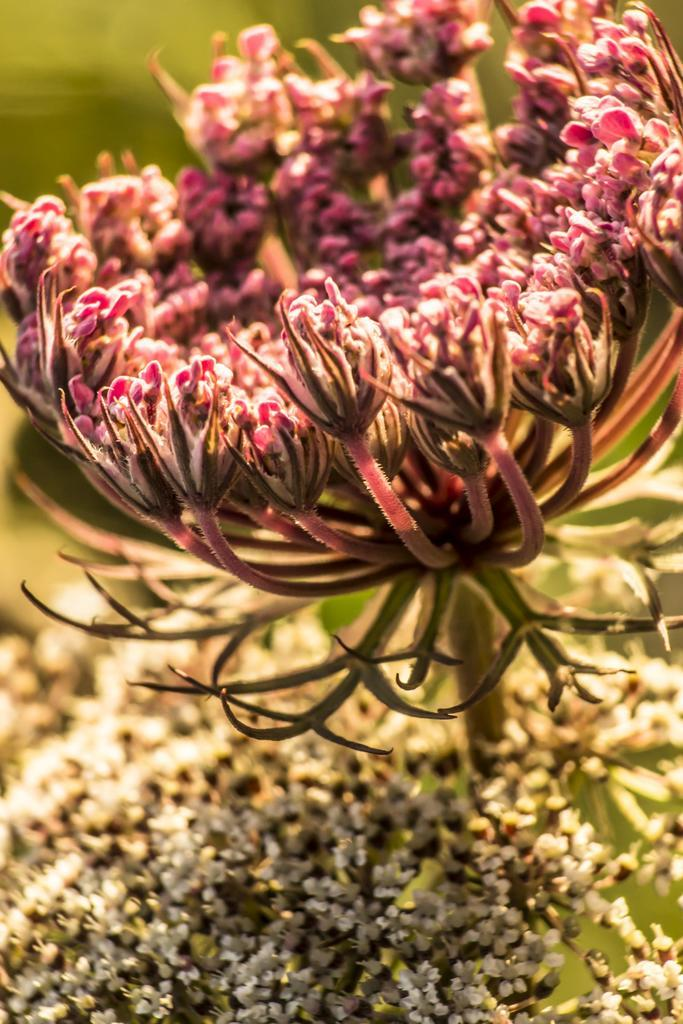What is the main subject of the image? There is a flower in the image. Can you describe the background of the image? The background of the image is blurred. How many birds are flying in the government square in the image? There are no birds, government, or square present in the image; it features a flower with a blurred background. 